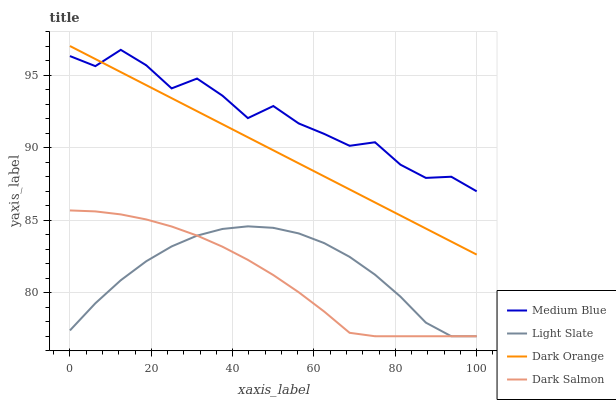Does Dark Salmon have the minimum area under the curve?
Answer yes or no. Yes. Does Medium Blue have the maximum area under the curve?
Answer yes or no. Yes. Does Dark Orange have the minimum area under the curve?
Answer yes or no. No. Does Dark Orange have the maximum area under the curve?
Answer yes or no. No. Is Dark Orange the smoothest?
Answer yes or no. Yes. Is Medium Blue the roughest?
Answer yes or no. Yes. Is Medium Blue the smoothest?
Answer yes or no. No. Is Dark Orange the roughest?
Answer yes or no. No. Does Light Slate have the lowest value?
Answer yes or no. Yes. Does Dark Orange have the lowest value?
Answer yes or no. No. Does Dark Orange have the highest value?
Answer yes or no. Yes. Does Medium Blue have the highest value?
Answer yes or no. No. Is Light Slate less than Dark Orange?
Answer yes or no. Yes. Is Medium Blue greater than Dark Salmon?
Answer yes or no. Yes. Does Dark Salmon intersect Light Slate?
Answer yes or no. Yes. Is Dark Salmon less than Light Slate?
Answer yes or no. No. Is Dark Salmon greater than Light Slate?
Answer yes or no. No. Does Light Slate intersect Dark Orange?
Answer yes or no. No. 